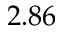Convert formula to latex. <formula><loc_0><loc_0><loc_500><loc_500>2 . 8 6</formula> 